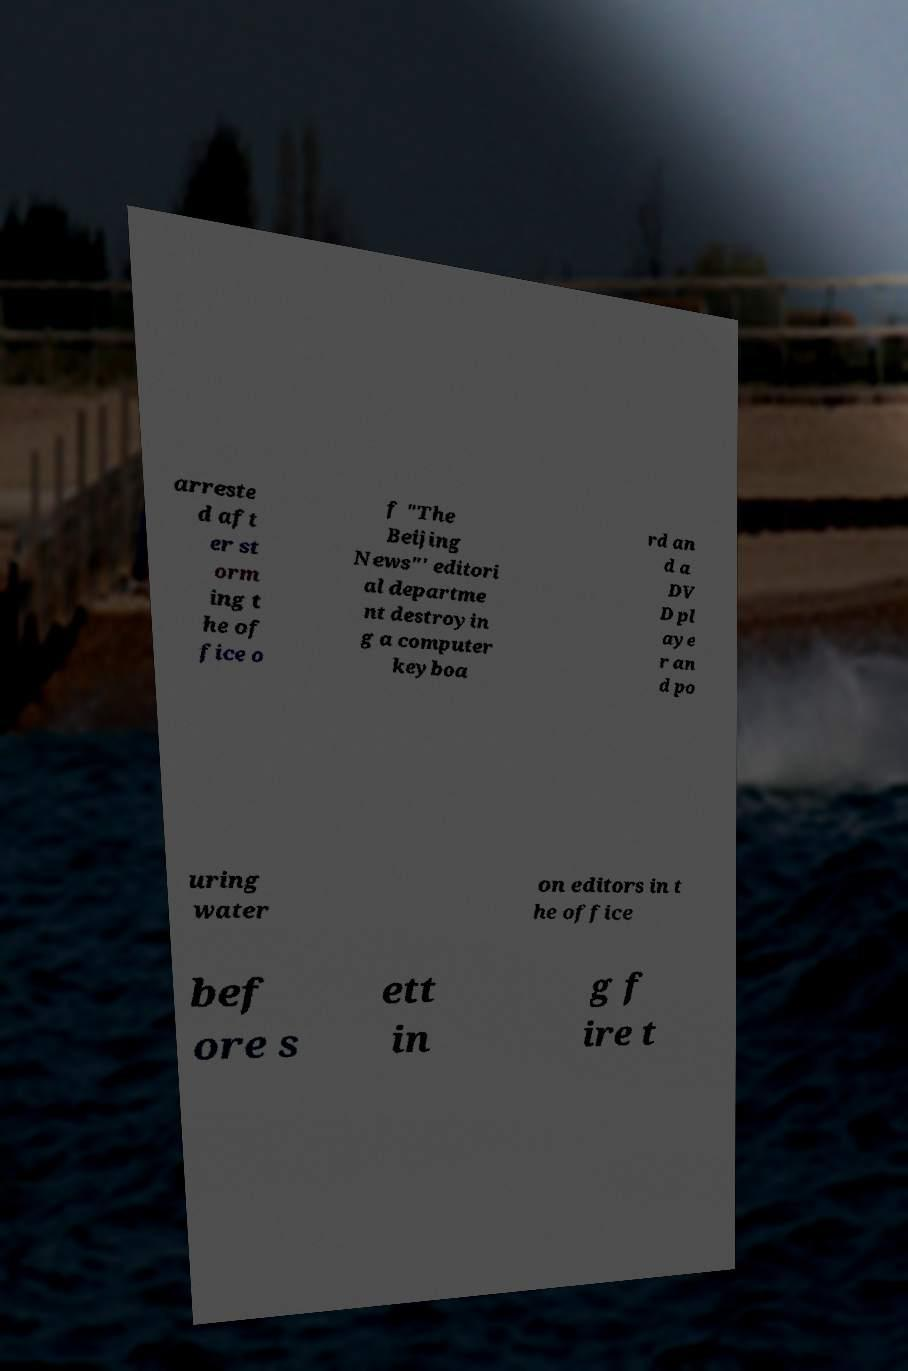I need the written content from this picture converted into text. Can you do that? arreste d aft er st orm ing t he of fice o f "The Beijing News"' editori al departme nt destroyin g a computer keyboa rd an d a DV D pl aye r an d po uring water on editors in t he office bef ore s ett in g f ire t 